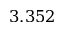Convert formula to latex. <formula><loc_0><loc_0><loc_500><loc_500>3 . 3 5 2</formula> 